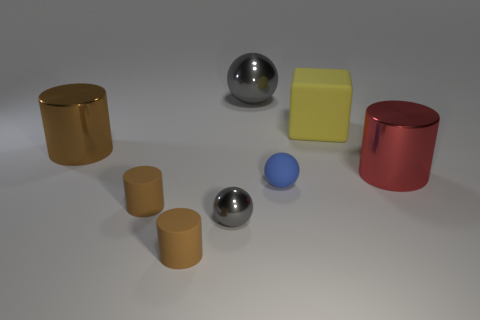Subtract all purple cubes. How many brown cylinders are left? 3 Add 1 small cylinders. How many objects exist? 9 Subtract all cubes. How many objects are left? 7 Subtract all small purple cylinders. Subtract all shiny things. How many objects are left? 4 Add 2 big matte blocks. How many big matte blocks are left? 3 Add 8 yellow rubber cubes. How many yellow rubber cubes exist? 9 Subtract 1 red cylinders. How many objects are left? 7 